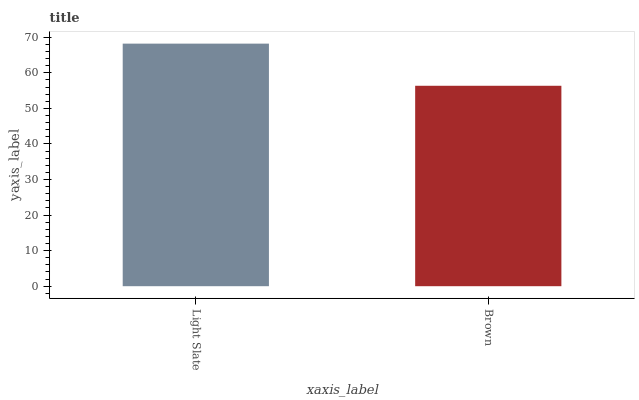Is Brown the minimum?
Answer yes or no. Yes. Is Light Slate the maximum?
Answer yes or no. Yes. Is Brown the maximum?
Answer yes or no. No. Is Light Slate greater than Brown?
Answer yes or no. Yes. Is Brown less than Light Slate?
Answer yes or no. Yes. Is Brown greater than Light Slate?
Answer yes or no. No. Is Light Slate less than Brown?
Answer yes or no. No. Is Light Slate the high median?
Answer yes or no. Yes. Is Brown the low median?
Answer yes or no. Yes. Is Brown the high median?
Answer yes or no. No. Is Light Slate the low median?
Answer yes or no. No. 